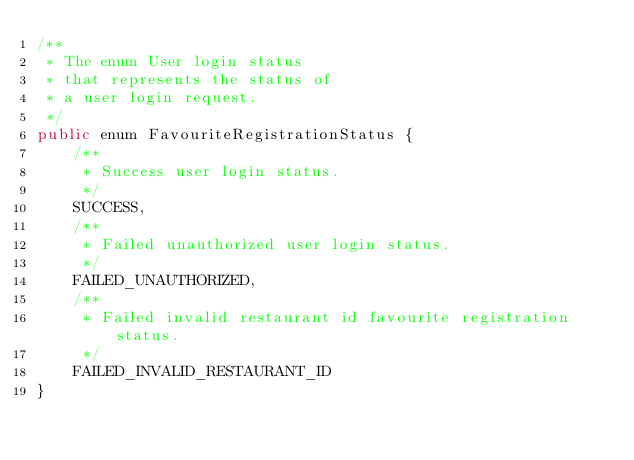<code> <loc_0><loc_0><loc_500><loc_500><_Java_>/**
 * The enum User login status
 * that represents the status of
 * a user login request.
 */
public enum FavouriteRegistrationStatus {
    /**
     * Success user login status.
     */
    SUCCESS,
    /**
     * Failed unauthorized user login status.
     */
    FAILED_UNAUTHORIZED,
    /**
     * Failed invalid restaurant id favourite registration status.
     */
    FAILED_INVALID_RESTAURANT_ID
}
</code> 